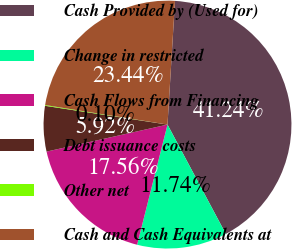Convert chart. <chart><loc_0><loc_0><loc_500><loc_500><pie_chart><fcel>Cash Provided by (Used for)<fcel>Change in restricted<fcel>Cash Flows from Financing<fcel>Debt issuance costs<fcel>Other net<fcel>Cash and Cash Equivalents at<nl><fcel>41.24%<fcel>11.74%<fcel>17.56%<fcel>5.92%<fcel>0.1%<fcel>23.44%<nl></chart> 